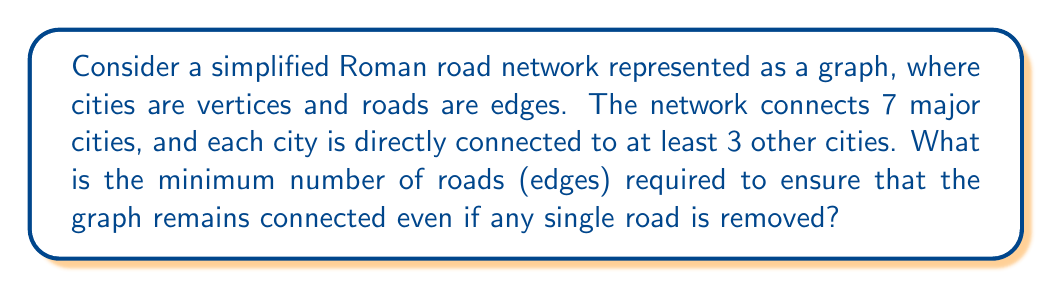Provide a solution to this math problem. To approach this problem, we need to consider the topological properties of the Roman road network:

1. We have 7 vertices (cities) in our graph.
2. Each vertex has a degree of at least 3 (connected to at least 3 other cities).
3. We want the graph to remain connected even if any single edge (road) is removed.

The concept we need to apply here is that of edge-connectivity. A graph is said to be k-edge-connected if it remains connected whenever fewer than k edges are removed. In our case, we want the graph to be 2-edge-connected.

To find the minimum number of edges, we can use the following steps:

1. First, calculate the minimum number of edges required for a graph with 7 vertices where each vertex has a degree of at least 3:

   $$\text{Minimum edges} = \frac{7 \times 3}{2} = \frac{21}{2} = 10.5$$

   Round up to the nearest integer: 11 edges.

2. However, this minimum might not ensure 2-edge-connectivity. To guarantee 2-edge-connectivity, we need to ensure that there are no bridges (edges whose removal would disconnect the graph) in our network.

3. The minimum number of edges for a 2-edge-connected graph with n vertices is n, which would form a cycle. But our graph needs more edges to satisfy the degree requirement.

4. Given the constraints, the minimum number of edges that satisfies both the degree requirement and 2-edge-connectivity is 11. This configuration would form a cycle of 7 edges (connecting all 7 cities) plus 4 additional edges to ensure each city has a degree of at least 3.

This configuration ensures that removing any single edge will not disconnect the graph, as there will always be an alternative path between any two cities.
Answer: 11 roads 